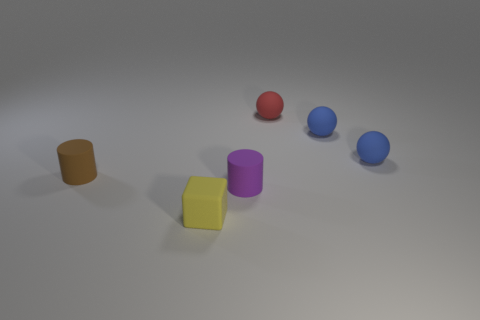Do the purple thing and the brown rubber cylinder have the same size?
Give a very brief answer. Yes. Are there any green things that have the same material as the red sphere?
Your response must be concise. No. What number of rubber objects are both on the right side of the tiny brown rubber thing and to the left of the red matte ball?
Give a very brief answer. 2. There is a small cylinder in front of the brown cylinder; what is its material?
Your response must be concise. Rubber. How many matte spheres are the same color as the matte block?
Your answer should be very brief. 0. What is the size of the purple object that is made of the same material as the tiny yellow block?
Ensure brevity in your answer.  Small. How many things are small yellow objects or tiny red matte things?
Make the answer very short. 2. There is a rubber cylinder that is left of the purple rubber cylinder; what is its color?
Offer a terse response. Brown. What size is the other thing that is the same shape as the small purple rubber object?
Offer a very short reply. Small. How many objects are either small matte cylinders to the right of the yellow matte object or cylinders to the left of the yellow block?
Your answer should be very brief. 2. 